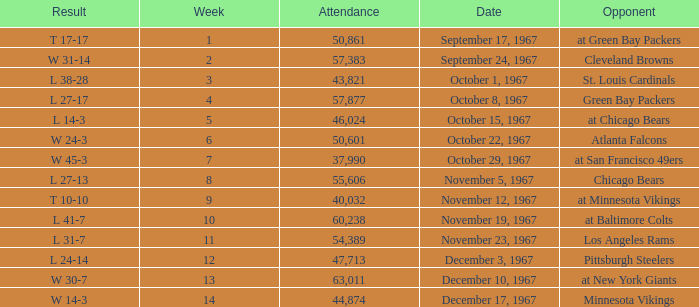How many weeks have a Result of t 10-10? 1.0. 